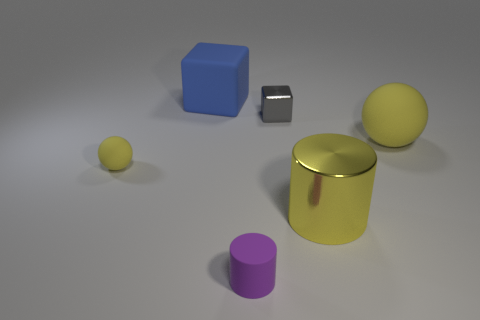What number of rubber balls are the same color as the metal cylinder?
Give a very brief answer. 2. Does the cylinder that is behind the purple matte cylinder have the same color as the big matte sphere?
Offer a terse response. Yes. Do the purple object and the tiny block have the same material?
Your response must be concise. No. There is a thing that is both in front of the small yellow rubber thing and to the left of the metallic block; what is its shape?
Keep it short and to the point. Cylinder. There is a matte object that is in front of the tiny object left of the large blue matte object; what size is it?
Ensure brevity in your answer.  Small. How many other big rubber objects have the same shape as the purple thing?
Give a very brief answer. 0. Is the big matte ball the same color as the big metal object?
Make the answer very short. Yes. Is there a sphere that has the same color as the large metal cylinder?
Your response must be concise. Yes. Is the big yellow object that is to the left of the large sphere made of the same material as the large yellow thing behind the small yellow thing?
Keep it short and to the point. No. What is the color of the small rubber cylinder?
Offer a terse response. Purple. 